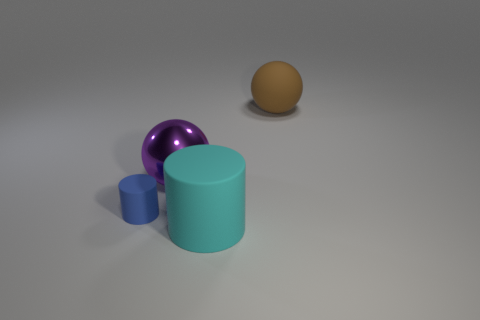Add 1 gray objects. How many objects exist? 5 Add 3 large yellow rubber things. How many large yellow rubber things exist? 3 Subtract 1 blue cylinders. How many objects are left? 3 Subtract all big brown matte spheres. Subtract all big blue cubes. How many objects are left? 3 Add 3 blue cylinders. How many blue cylinders are left? 4 